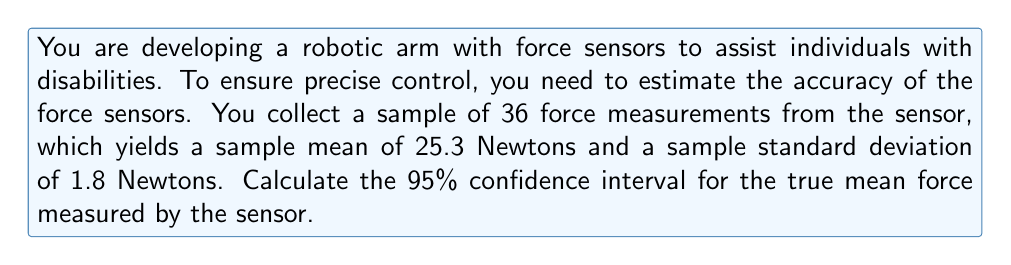Teach me how to tackle this problem. To calculate the confidence interval, we'll follow these steps:

1. Identify the given information:
   - Sample size: $n = 36$
   - Sample mean: $\bar{x} = 25.3$ N
   - Sample standard deviation: $s = 1.8$ N
   - Confidence level: 95%

2. Determine the critical value:
   For a 95% confidence interval with 35 degrees of freedom (n-1), we use the t-distribution. The critical value is $t_{0.025, 35} = 2.030$.

3. Calculate the margin of error:
   Margin of error = $t_{0.025, 35} \cdot \frac{s}{\sqrt{n}}$
   $$ \text{Margin of error} = 2.030 \cdot \frac{1.8}{\sqrt{36}} = 0.61 \text{ N} $$

4. Compute the confidence interval:
   Lower bound = $\bar{x} - \text{Margin of error}$
   Upper bound = $\bar{x} + \text{Margin of error}$

   $$ 25.3 - 0.61 \leq \mu \leq 25.3 + 0.61 $$
   $$ 24.69 \text{ N} \leq \mu \leq 25.91 \text{ N} $$

Therefore, we can be 95% confident that the true mean force measured by the sensor falls between 24.69 N and 25.91 N.
Answer: (24.69 N, 25.91 N) 